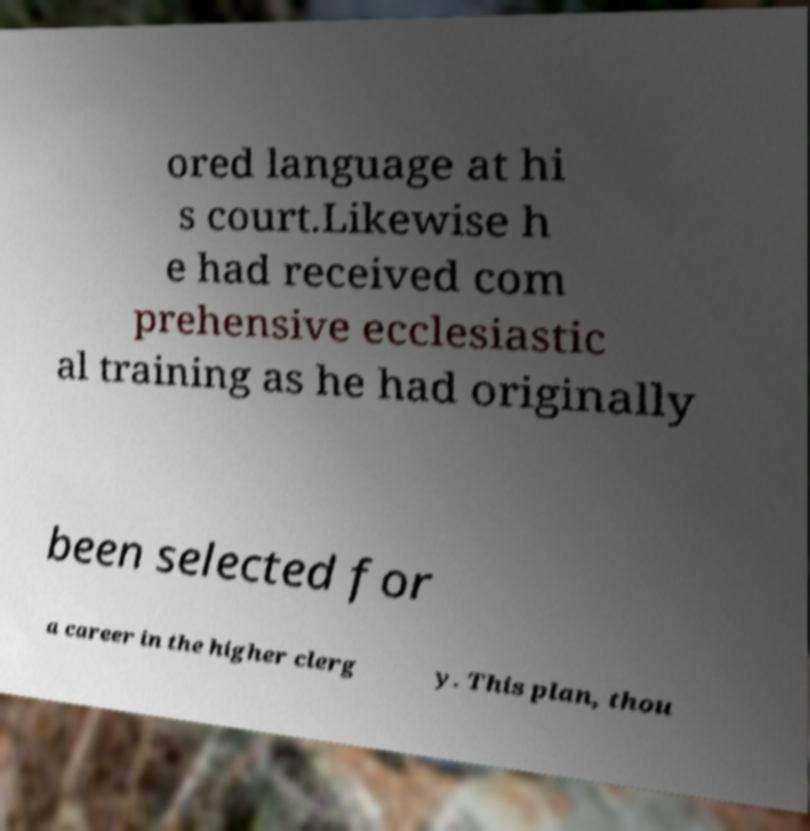Please read and relay the text visible in this image. What does it say? ored language at hi s court.Likewise h e had received com prehensive ecclesiastic al training as he had originally been selected for a career in the higher clerg y. This plan, thou 